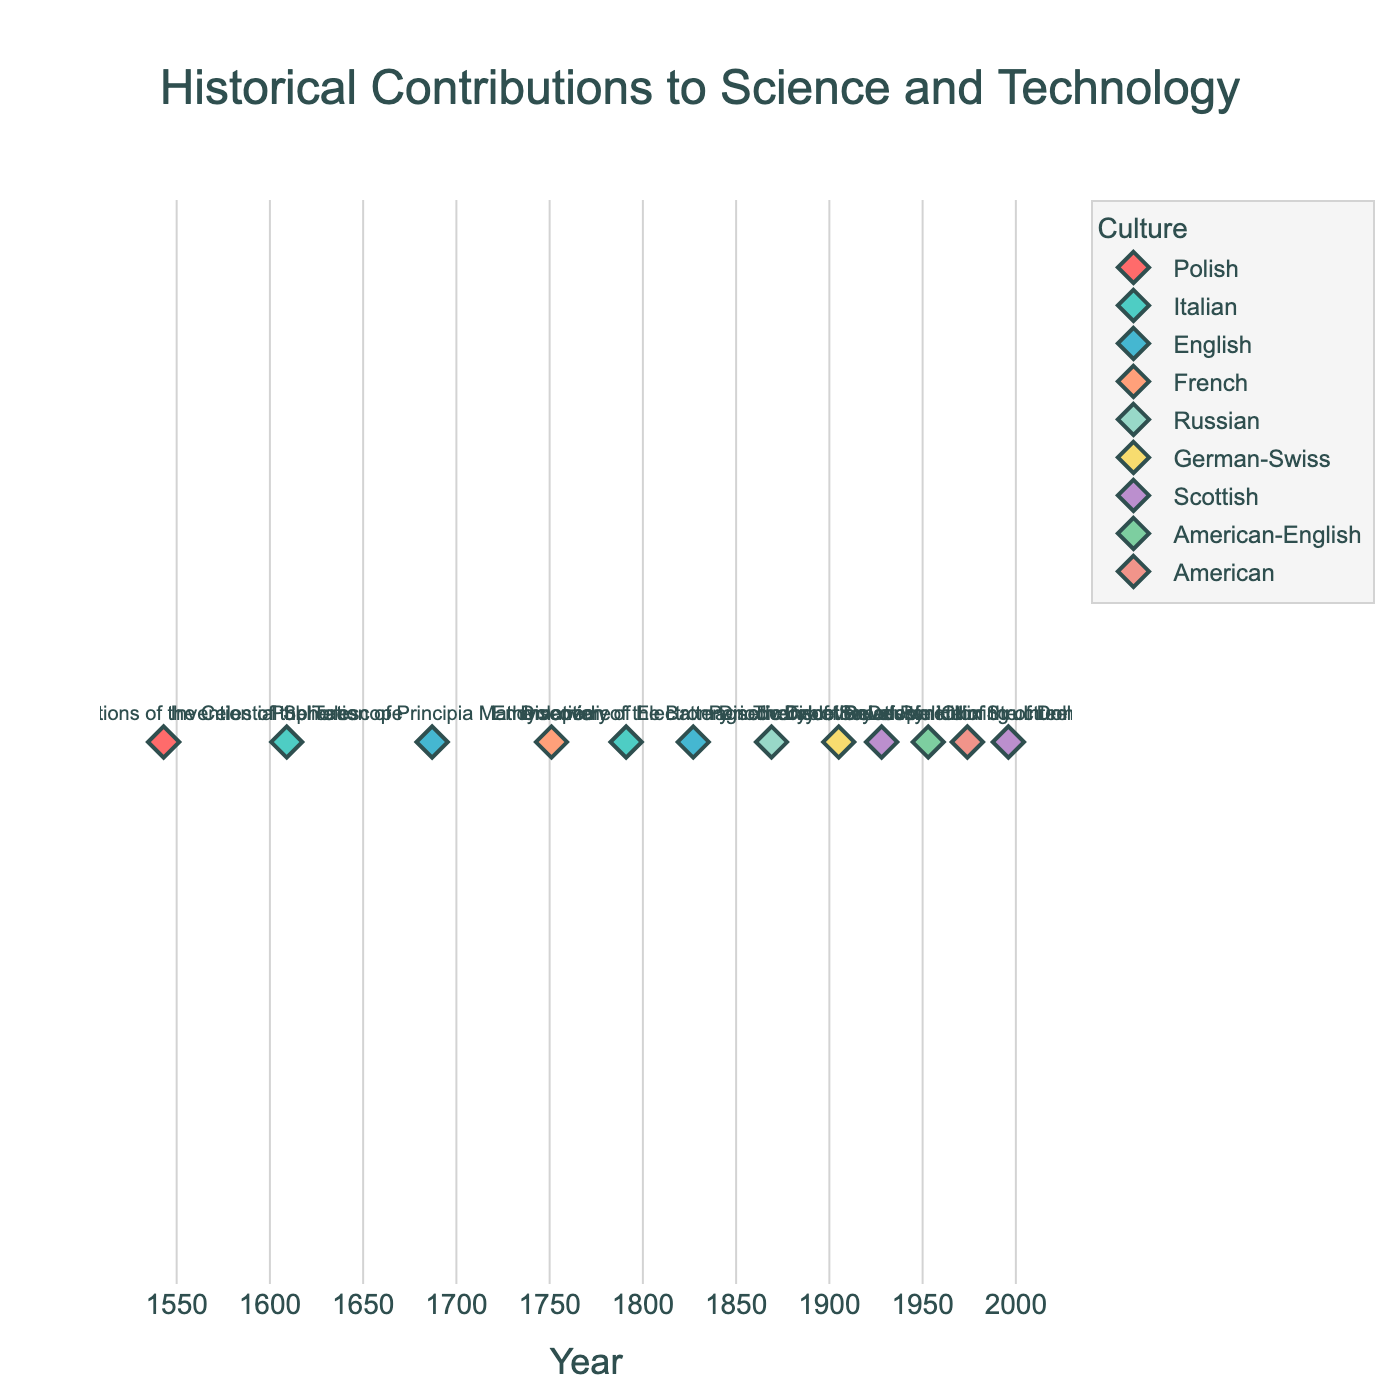What's the title of the plot? The title of the plot is displayed at the top of the figure in large font.
Answer: Historical Contributions to Science and Technology How many contributions are shown for Italian culture? By counting the markers associated with the Italian culture label, we see markers for the "Invention of the Telescope" and the "Invention of the Battery."
Answer: 2 Which contributor has a contribution in the earliest year? By examining the x-axis, the contribution in the earliest year is marked in 1543, attributed to Nicolaus Copernicus.
Answer: Nicolaus Copernicus Between which years are the contributions spread out? The first and last years on the x-axis markers represent the spread, which begin in 1543 and end in 1996.
Answer: 1543 and 1996 How many unique cultures are represented in the plot? Each unique color and legend item represent distinct cultures; counting them, we get 11.
Answer: 11 What is the median year of the contributions? Listing the years (1543, 1609, 1687, 1751, 1791, 1827, 1869, 1905, 1928, 1953, 1974, 1996) and finding the middle value(s), the median year lies between 1869 and 1905. (1869+1905)/2 = 1887
Answer: 1887 Identify the two contributions made by Scottish contributors. By checking the markers labeled "Scottish," we find Alexander Fleming's "Discovery of Penicillin" (1928) and Wilmut et al.'s "Successful Cloning of Dolly the Sheep" (1996).
Answer: Discovery of Penicillin and Successful Cloning of Dolly the Sheep Which culture has contributions closest to each other in time? By observing the x-axis distance between contributions, Italian culture’s contributions in 1609 and 1791 are closer (182-year gap) compared to others with larger gaps.
Answer: Italian Which contribution is closest in time to the discovery of the double helix structure of DNA? Looking at the nearest year to 1953 for the discovery, the closest contribution is "Development of the Internet" in 1974, a 21-year gap.
Answer: Development of the Internet Calculate the average year of contributions for the English culture. Listing the years (1687, 1827, 1953) for English contributions and averaging (1687 + 1827 + 1953)/3 = 1822.33.
Answer: 1822.33 